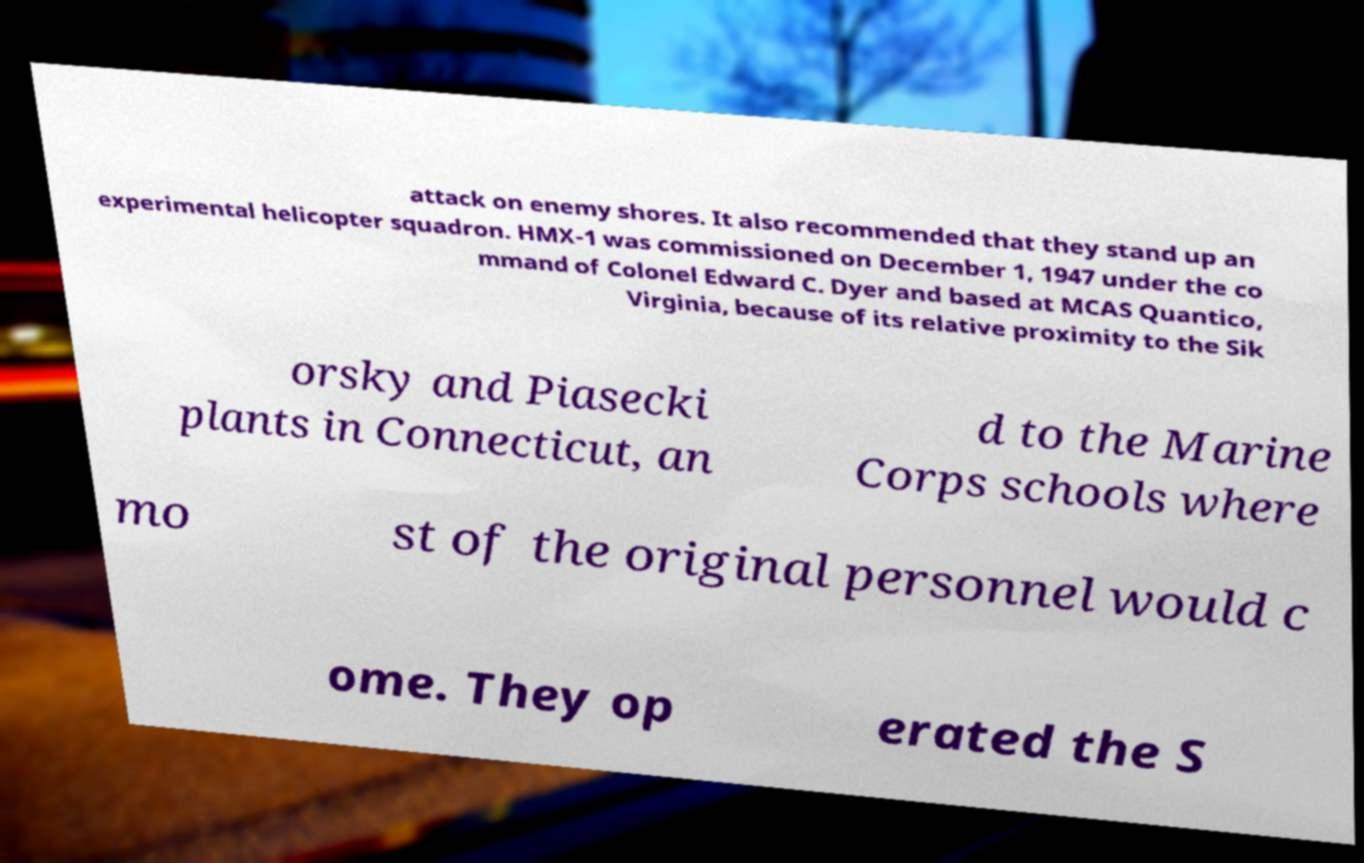There's text embedded in this image that I need extracted. Can you transcribe it verbatim? attack on enemy shores. It also recommended that they stand up an experimental helicopter squadron. HMX-1 was commissioned on December 1, 1947 under the co mmand of Colonel Edward C. Dyer and based at MCAS Quantico, Virginia, because of its relative proximity to the Sik orsky and Piasecki plants in Connecticut, an d to the Marine Corps schools where mo st of the original personnel would c ome. They op erated the S 